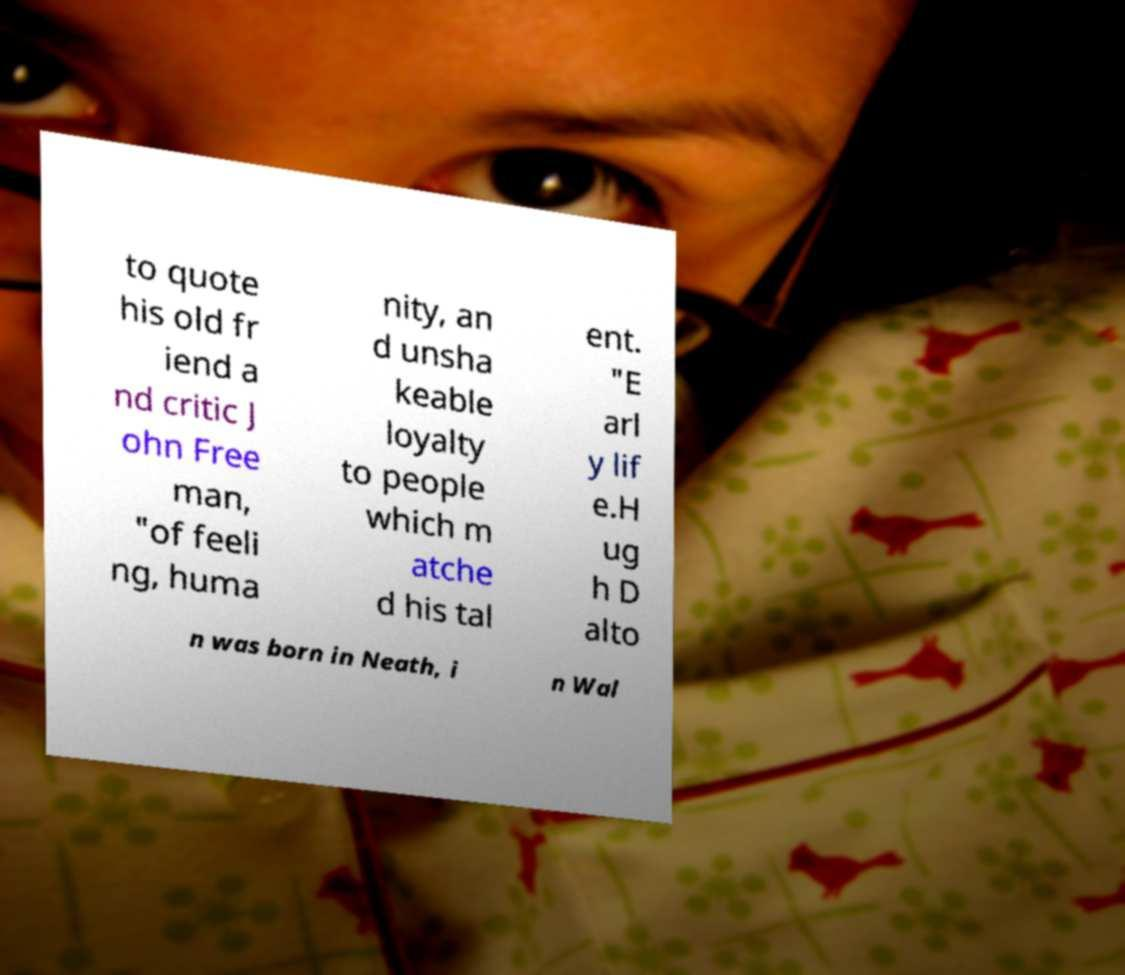For documentation purposes, I need the text within this image transcribed. Could you provide that? to quote his old fr iend a nd critic J ohn Free man, "of feeli ng, huma nity, an d unsha keable loyalty to people which m atche d his tal ent. "E arl y lif e.H ug h D alto n was born in Neath, i n Wal 